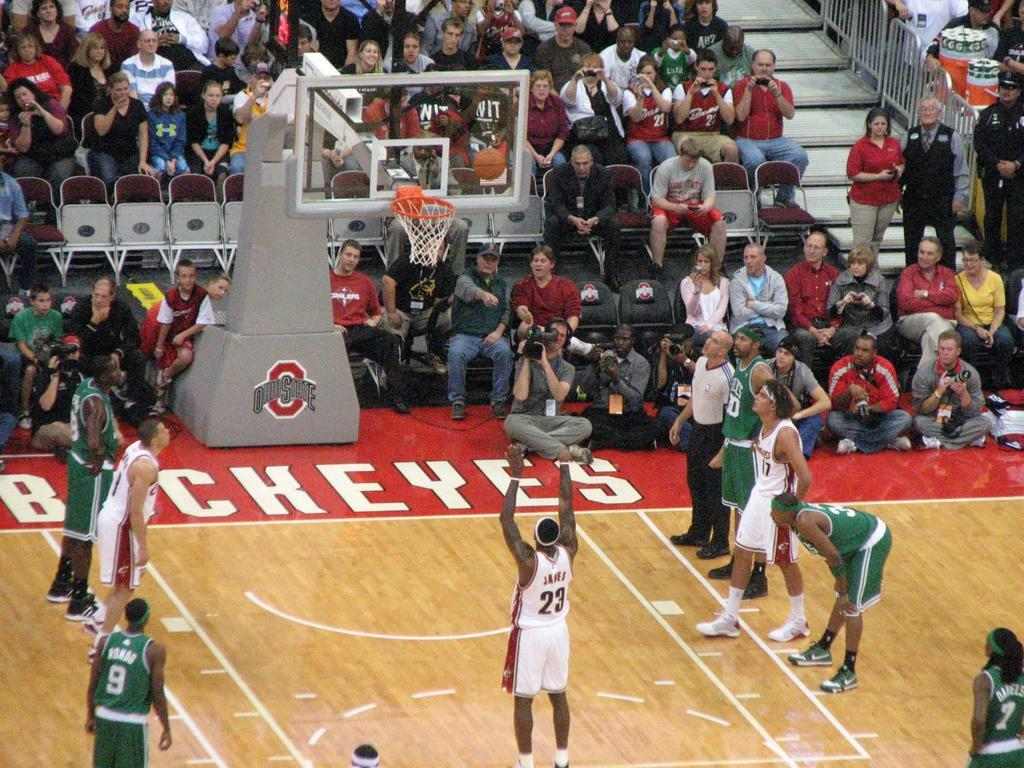<image>
Relay a brief, clear account of the picture shown. Two teams play one another on an Ohio State Buckeyes basketball court 